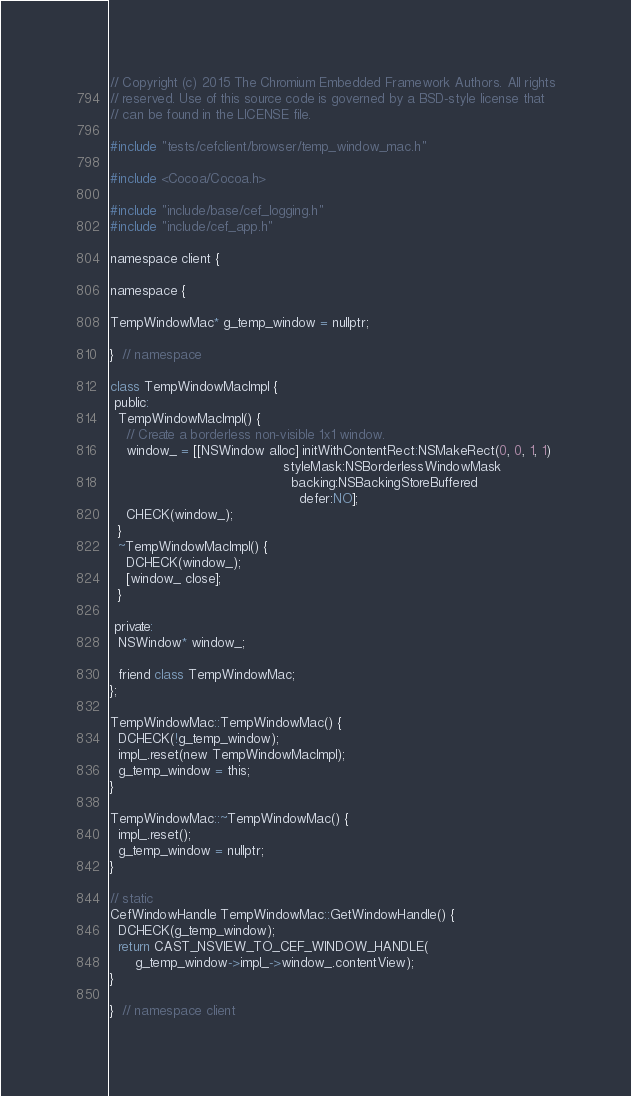<code> <loc_0><loc_0><loc_500><loc_500><_ObjectiveC_>// Copyright (c) 2015 The Chromium Embedded Framework Authors. All rights
// reserved. Use of this source code is governed by a BSD-style license that
// can be found in the LICENSE file.

#include "tests/cefclient/browser/temp_window_mac.h"

#include <Cocoa/Cocoa.h>

#include "include/base/cef_logging.h"
#include "include/cef_app.h"

namespace client {

namespace {

TempWindowMac* g_temp_window = nullptr;

}  // namespace

class TempWindowMacImpl {
 public:
  TempWindowMacImpl() {
    // Create a borderless non-visible 1x1 window.
    window_ = [[NSWindow alloc] initWithContentRect:NSMakeRect(0, 0, 1, 1)
                                          styleMask:NSBorderlessWindowMask
                                            backing:NSBackingStoreBuffered
                                              defer:NO];
    CHECK(window_);
  }
  ~TempWindowMacImpl() {
    DCHECK(window_);
    [window_ close];
  }

 private:
  NSWindow* window_;

  friend class TempWindowMac;
};

TempWindowMac::TempWindowMac() {
  DCHECK(!g_temp_window);
  impl_.reset(new TempWindowMacImpl);
  g_temp_window = this;
}

TempWindowMac::~TempWindowMac() {
  impl_.reset();
  g_temp_window = nullptr;
}

// static
CefWindowHandle TempWindowMac::GetWindowHandle() {
  DCHECK(g_temp_window);
  return CAST_NSVIEW_TO_CEF_WINDOW_HANDLE(
      g_temp_window->impl_->window_.contentView);
}

}  // namespace client
</code> 